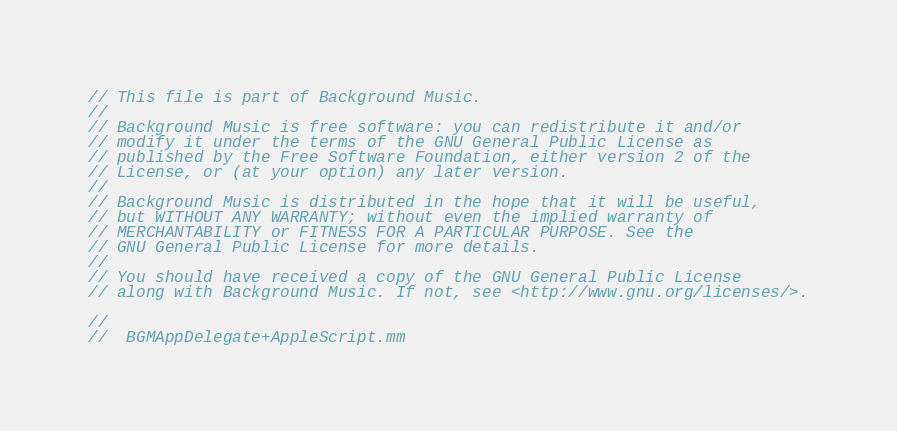Convert code to text. <code><loc_0><loc_0><loc_500><loc_500><_ObjectiveC_>// This file is part of Background Music.
//
// Background Music is free software: you can redistribute it and/or
// modify it under the terms of the GNU General Public License as
// published by the Free Software Foundation, either version 2 of the
// License, or (at your option) any later version.
//
// Background Music is distributed in the hope that it will be useful,
// but WITHOUT ANY WARRANTY; without even the implied warranty of
// MERCHANTABILITY or FITNESS FOR A PARTICULAR PURPOSE. See the
// GNU General Public License for more details.
//
// You should have received a copy of the GNU General Public License
// along with Background Music. If not, see <http://www.gnu.org/licenses/>.

//
//  BGMAppDelegate+AppleScript.mm</code> 